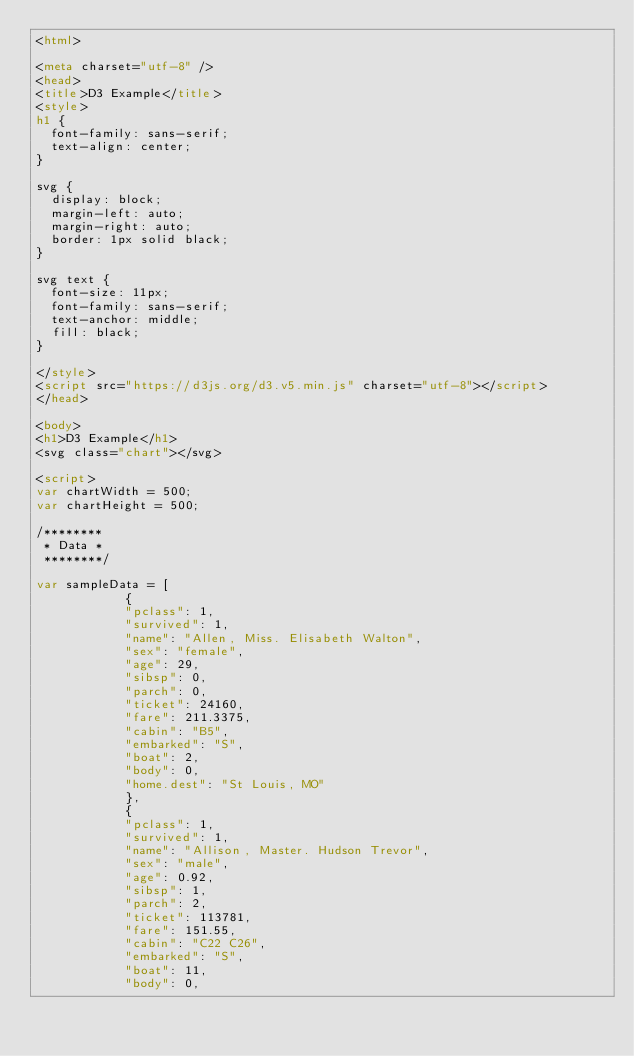Convert code to text. <code><loc_0><loc_0><loc_500><loc_500><_HTML_><html>

<meta charset="utf-8" />
<head>
<title>D3 Example</title>
<style>
h1 { 
  font-family: sans-serif;
  text-align: center;
}

svg {
  display: block;
  margin-left: auto;
  margin-right: auto;
  border: 1px solid black;
}

svg text {
  font-size: 11px;
  font-family: sans-serif;
  text-anchor: middle;
  fill: black;
}

</style>
<script src="https://d3js.org/d3.v5.min.js" charset="utf-8"></script>
</head>

<body>
<h1>D3 Example</h1>
<svg class="chart"></svg>

<script>
var chartWidth = 500;
var chartHeight = 500;

/********
 * Data *
 ********/

var sampleData = [
            {
            "pclass": 1,
            "survived": 1,
            "name": "Allen, Miss. Elisabeth Walton",
            "sex": "female",
            "age": 29,
            "sibsp": 0,
            "parch": 0,
            "ticket": 24160,
            "fare": 211.3375,
            "cabin": "B5",
            "embarked": "S",
            "boat": 2,
            "body": 0,
            "home.dest": "St Louis, MO"
            },
            {
            "pclass": 1,
            "survived": 1,
            "name": "Allison, Master. Hudson Trevor",
            "sex": "male",
            "age": 0.92,
            "sibsp": 1,
            "parch": 2,
            "ticket": 113781,
            "fare": 151.55,
            "cabin": "C22 C26",
            "embarked": "S",
            "boat": 11,
            "body": 0,</code> 